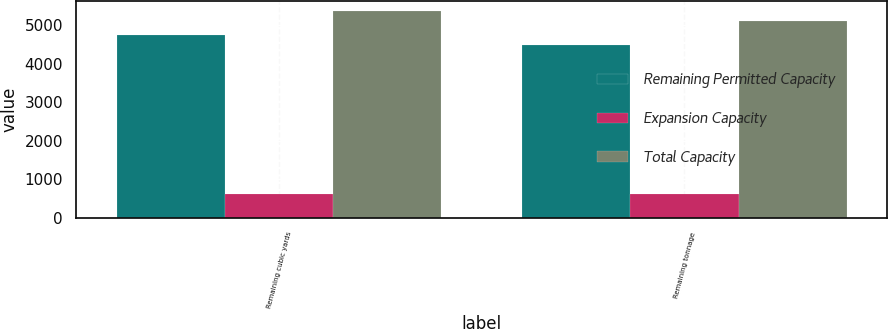Convert chart. <chart><loc_0><loc_0><loc_500><loc_500><stacked_bar_chart><ecel><fcel>Remaining cubic yards<fcel>Remaining tonnage<nl><fcel>Remaining Permitted Capacity<fcel>4730<fcel>4485<nl><fcel>Expansion Capacity<fcel>621<fcel>621<nl><fcel>Total Capacity<fcel>5351<fcel>5106<nl></chart> 